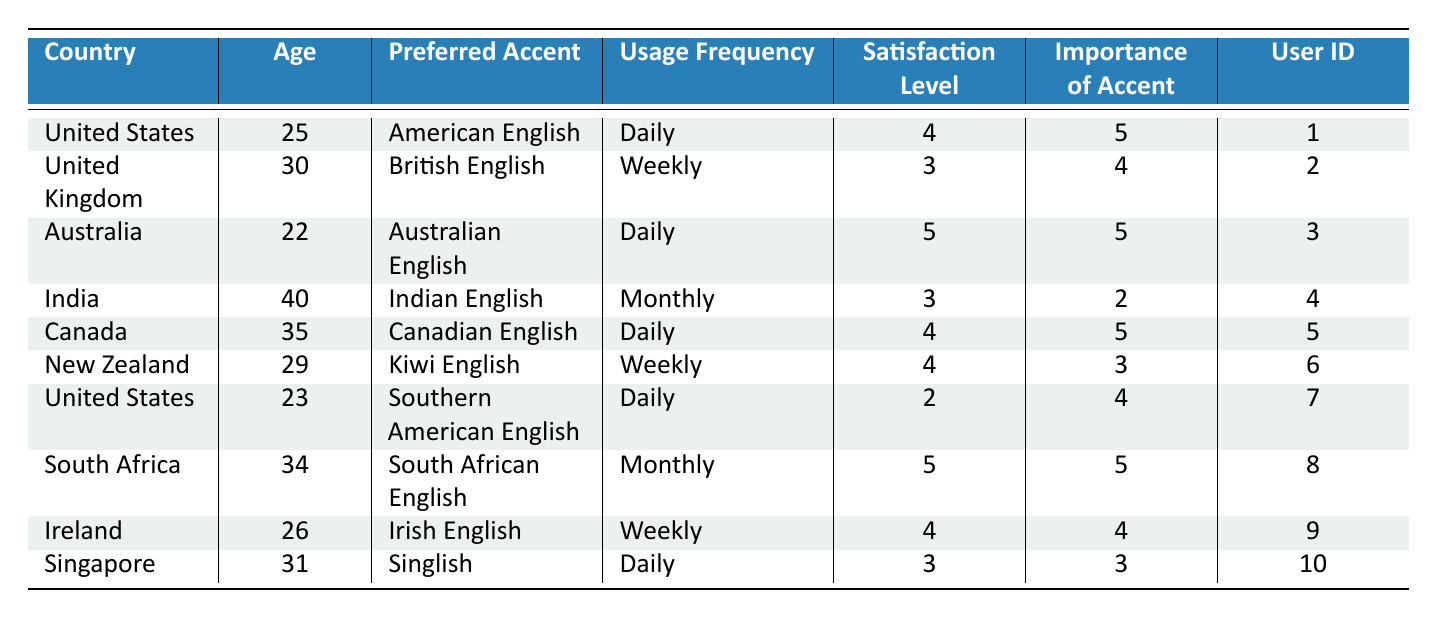What is the preferred accent of the user from Canada? The entry for Canada lists "Canadian English" as the preferred accent for the user from that country.
Answer: Canadian English What is the satisfaction level of the user who prefers Singlish? The user who prefers Singlish has a satisfaction level of 3 as indicated in the table.
Answer: 3 How many users use voice assistants daily? By counting the entries that indicate "Daily" under usage frequency, we find that there are 5 users with that frequency.
Answer: 5 What is the average importance of accent among all surveyed users? The importance levels are 5, 4, 5, 2, 5, 3, 4, 5, 4, and 3. Summing these values gives 5 + 4 + 5 + 2 + 5 + 3 + 4 + 5 + 4 + 3 = 46. There are 10 users, so the average is 46 / 10 = 4.6.
Answer: 4.6 Is there a user who prefers Southern American English and has a satisfaction level of 4? The user who prefers Southern American English has a satisfaction level of 2, not 4; therefore, the answer is no.
Answer: No Which country has the highest satisfaction level? The highest satisfaction level recorded in the table is 5, seen in users from Australia and South Africa. Therefore, both countries have the highest satisfaction level.
Answer: Australia and South Africa How many users from the United States use their voice assistants daily? There are two users from the United States listed; both have a usage frequency of daily.
Answer: 2 What is the median age of users who prefer an English accent? The ages of users who prefer an English accent are: 25, 30, 22, 40, 35, 29, 23, 34, 26, 31. Arranging these gives: 22, 23, 25, 26, 29, 30, 31, 34, 35, 40. With ten users, the median is the average of the 5th and 6th numbers: (29 + 30) / 2 = 29.5.
Answer: 29.5 Which accent had the lowest importance rating? The lowest importance rating in the table is 2, associated with the user who prefers Indian English.
Answer: Indian English Is a higher satisfaction level correlated with a higher importance of accent based on the data provided? Analyzing the satisfaction levels and importance ratings, there is a correlation where higher satisfaction levels often correspond to higher importance ratings; however, this is not consistently true for all users, indicating a weak correlation at best.
Answer: No 